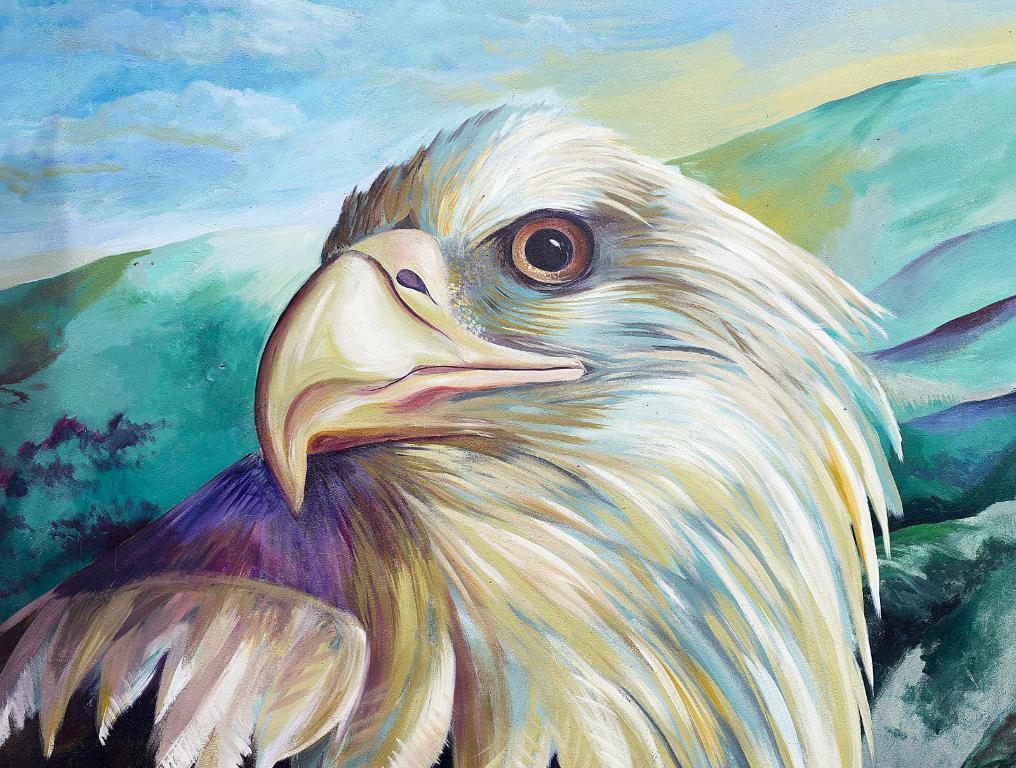Can you describe this image briefly? In this picture we can see a painting of an eagle and some clouds. 